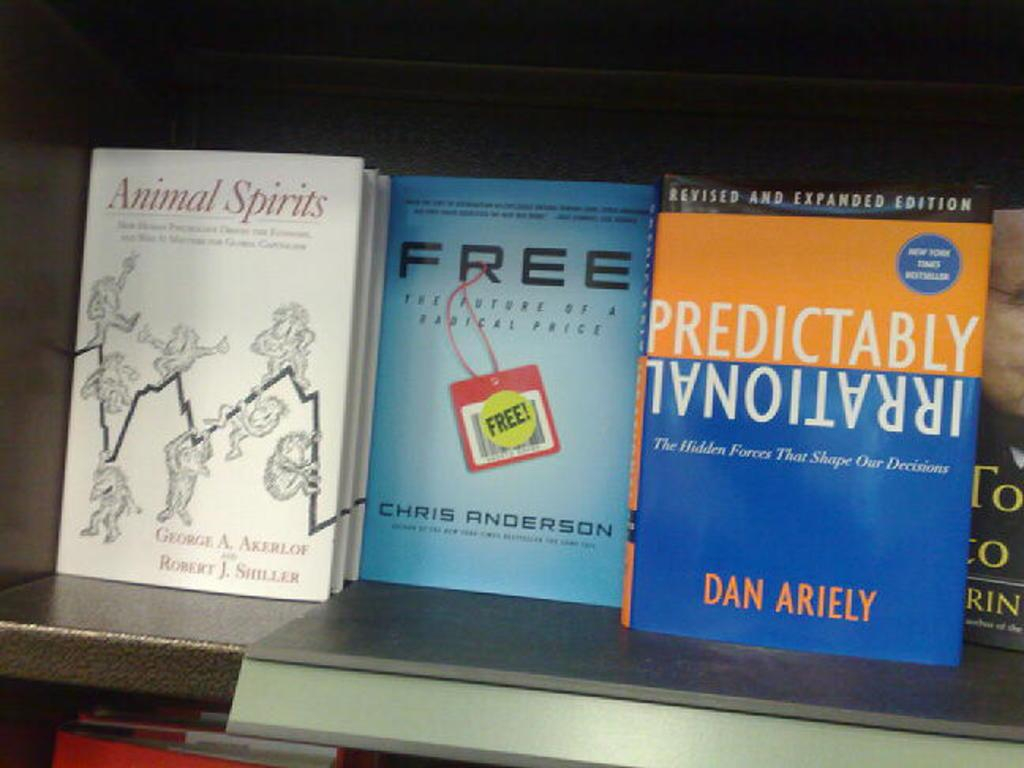<image>
Create a compact narrative representing the image presented. the name dan is on one of the books 